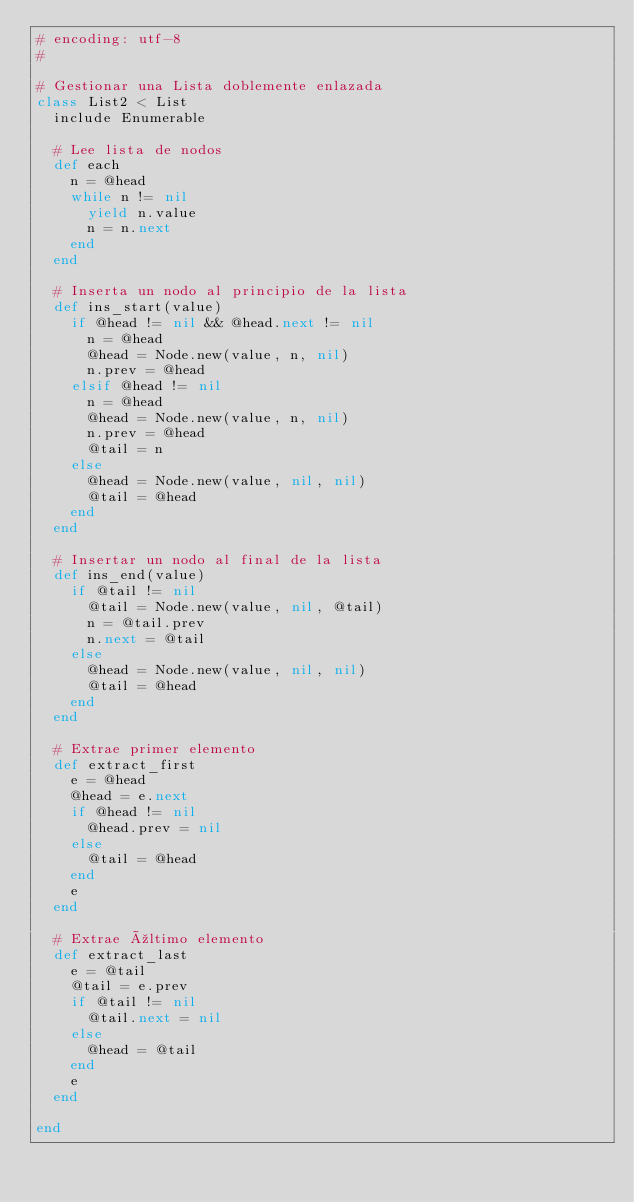<code> <loc_0><loc_0><loc_500><loc_500><_Ruby_># encoding: utf-8
#

# Gestionar una Lista doblemente enlazada
class List2 < List
  include Enumerable

  # Lee lista de nodos
  def each
    n = @head
    while n != nil
      yield n.value
      n = n.next
    end  
  end
  
  # Inserta un nodo al principio de la lista
  def ins_start(value)
    if @head != nil && @head.next != nil
      n = @head
      @head = Node.new(value, n, nil)
      n.prev = @head
    elsif @head != nil
      n = @head
      @head = Node.new(value, n, nil)
      n.prev = @head
      @tail = n
    else
      @head = Node.new(value, nil, nil)
      @tail = @head
    end
  end
 
  # Insertar un nodo al final de la lista
  def ins_end(value)
    if @tail != nil
      @tail = Node.new(value, nil, @tail)
      n = @tail.prev
      n.next = @tail
    else
      @head = Node.new(value, nil, nil)
      @tail = @head
    end
  end
  
  # Extrae primer elemento
  def extract_first
    e = @head
    @head = e.next
    if @head != nil
      @head.prev = nil
    else
      @tail = @head
    end
    e
  end  
  
  # Extrae último elemento
  def extract_last
    e = @tail
    @tail = e.prev
    if @tail != nil
      @tail.next = nil
    else
      @head = @tail
    end
    e
  end  

end</code> 